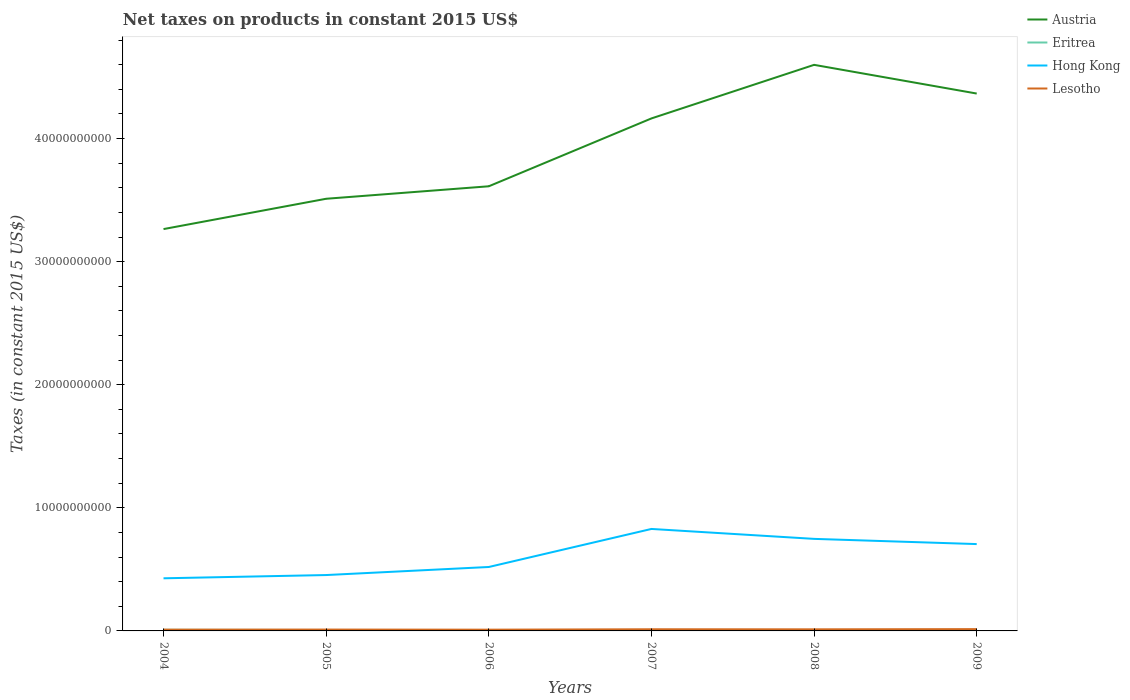Does the line corresponding to Austria intersect with the line corresponding to Lesotho?
Your answer should be very brief. No. Is the number of lines equal to the number of legend labels?
Ensure brevity in your answer.  Yes. Across all years, what is the maximum net taxes on products in Eritrea?
Your answer should be compact. 4.81e+07. In which year was the net taxes on products in Eritrea maximum?
Offer a very short reply. 2008. What is the total net taxes on products in Austria in the graph?
Your response must be concise. -6.53e+09. What is the difference between the highest and the second highest net taxes on products in Eritrea?
Keep it short and to the point. 4.13e+07. Is the net taxes on products in Austria strictly greater than the net taxes on products in Lesotho over the years?
Your answer should be compact. No. How many lines are there?
Provide a succinct answer. 4. Does the graph contain any zero values?
Your answer should be compact. No. Does the graph contain grids?
Keep it short and to the point. No. Where does the legend appear in the graph?
Provide a succinct answer. Top right. How many legend labels are there?
Ensure brevity in your answer.  4. What is the title of the graph?
Provide a succinct answer. Net taxes on products in constant 2015 US$. What is the label or title of the Y-axis?
Provide a short and direct response. Taxes (in constant 2015 US$). What is the Taxes (in constant 2015 US$) of Austria in 2004?
Provide a short and direct response. 3.26e+1. What is the Taxes (in constant 2015 US$) of Eritrea in 2004?
Make the answer very short. 8.94e+07. What is the Taxes (in constant 2015 US$) in Hong Kong in 2004?
Your answer should be very brief. 4.28e+09. What is the Taxes (in constant 2015 US$) of Lesotho in 2004?
Your answer should be very brief. 1.04e+08. What is the Taxes (in constant 2015 US$) in Austria in 2005?
Your answer should be compact. 3.51e+1. What is the Taxes (in constant 2015 US$) of Eritrea in 2005?
Your answer should be very brief. 7.30e+07. What is the Taxes (in constant 2015 US$) in Hong Kong in 2005?
Provide a succinct answer. 4.54e+09. What is the Taxes (in constant 2015 US$) in Lesotho in 2005?
Ensure brevity in your answer.  1.10e+08. What is the Taxes (in constant 2015 US$) of Austria in 2006?
Ensure brevity in your answer.  3.61e+1. What is the Taxes (in constant 2015 US$) of Eritrea in 2006?
Your answer should be very brief. 7.00e+07. What is the Taxes (in constant 2015 US$) of Hong Kong in 2006?
Your response must be concise. 5.19e+09. What is the Taxes (in constant 2015 US$) in Lesotho in 2006?
Your response must be concise. 1.01e+08. What is the Taxes (in constant 2015 US$) of Austria in 2007?
Your answer should be very brief. 4.16e+1. What is the Taxes (in constant 2015 US$) in Eritrea in 2007?
Provide a succinct answer. 5.80e+07. What is the Taxes (in constant 2015 US$) in Hong Kong in 2007?
Your response must be concise. 8.28e+09. What is the Taxes (in constant 2015 US$) in Lesotho in 2007?
Offer a very short reply. 1.34e+08. What is the Taxes (in constant 2015 US$) in Austria in 2008?
Offer a terse response. 4.60e+1. What is the Taxes (in constant 2015 US$) of Eritrea in 2008?
Your answer should be compact. 4.81e+07. What is the Taxes (in constant 2015 US$) of Hong Kong in 2008?
Your answer should be very brief. 7.48e+09. What is the Taxes (in constant 2015 US$) in Lesotho in 2008?
Your answer should be compact. 1.29e+08. What is the Taxes (in constant 2015 US$) of Austria in 2009?
Your answer should be compact. 4.37e+1. What is the Taxes (in constant 2015 US$) in Eritrea in 2009?
Offer a terse response. 5.17e+07. What is the Taxes (in constant 2015 US$) of Hong Kong in 2009?
Make the answer very short. 7.06e+09. What is the Taxes (in constant 2015 US$) of Lesotho in 2009?
Offer a terse response. 1.45e+08. Across all years, what is the maximum Taxes (in constant 2015 US$) in Austria?
Make the answer very short. 4.60e+1. Across all years, what is the maximum Taxes (in constant 2015 US$) in Eritrea?
Provide a succinct answer. 8.94e+07. Across all years, what is the maximum Taxes (in constant 2015 US$) in Hong Kong?
Give a very brief answer. 8.28e+09. Across all years, what is the maximum Taxes (in constant 2015 US$) of Lesotho?
Provide a short and direct response. 1.45e+08. Across all years, what is the minimum Taxes (in constant 2015 US$) in Austria?
Give a very brief answer. 3.26e+1. Across all years, what is the minimum Taxes (in constant 2015 US$) of Eritrea?
Offer a very short reply. 4.81e+07. Across all years, what is the minimum Taxes (in constant 2015 US$) in Hong Kong?
Keep it short and to the point. 4.28e+09. Across all years, what is the minimum Taxes (in constant 2015 US$) of Lesotho?
Provide a succinct answer. 1.01e+08. What is the total Taxes (in constant 2015 US$) in Austria in the graph?
Keep it short and to the point. 2.35e+11. What is the total Taxes (in constant 2015 US$) in Eritrea in the graph?
Your answer should be very brief. 3.90e+08. What is the total Taxes (in constant 2015 US$) in Hong Kong in the graph?
Ensure brevity in your answer.  3.68e+1. What is the total Taxes (in constant 2015 US$) of Lesotho in the graph?
Make the answer very short. 7.24e+08. What is the difference between the Taxes (in constant 2015 US$) in Austria in 2004 and that in 2005?
Keep it short and to the point. -2.46e+09. What is the difference between the Taxes (in constant 2015 US$) of Eritrea in 2004 and that in 2005?
Your answer should be compact. 1.64e+07. What is the difference between the Taxes (in constant 2015 US$) of Hong Kong in 2004 and that in 2005?
Your response must be concise. -2.64e+08. What is the difference between the Taxes (in constant 2015 US$) in Lesotho in 2004 and that in 2005?
Make the answer very short. -6.22e+06. What is the difference between the Taxes (in constant 2015 US$) in Austria in 2004 and that in 2006?
Ensure brevity in your answer.  -3.48e+09. What is the difference between the Taxes (in constant 2015 US$) in Eritrea in 2004 and that in 2006?
Make the answer very short. 1.94e+07. What is the difference between the Taxes (in constant 2015 US$) of Hong Kong in 2004 and that in 2006?
Your answer should be very brief. -9.19e+08. What is the difference between the Taxes (in constant 2015 US$) of Lesotho in 2004 and that in 2006?
Your answer should be very brief. 2.85e+06. What is the difference between the Taxes (in constant 2015 US$) of Austria in 2004 and that in 2007?
Your response must be concise. -8.99e+09. What is the difference between the Taxes (in constant 2015 US$) in Eritrea in 2004 and that in 2007?
Give a very brief answer. 3.14e+07. What is the difference between the Taxes (in constant 2015 US$) in Hong Kong in 2004 and that in 2007?
Your response must be concise. -4.01e+09. What is the difference between the Taxes (in constant 2015 US$) in Lesotho in 2004 and that in 2007?
Provide a short and direct response. -3.01e+07. What is the difference between the Taxes (in constant 2015 US$) in Austria in 2004 and that in 2008?
Ensure brevity in your answer.  -1.33e+1. What is the difference between the Taxes (in constant 2015 US$) in Eritrea in 2004 and that in 2008?
Ensure brevity in your answer.  4.13e+07. What is the difference between the Taxes (in constant 2015 US$) of Hong Kong in 2004 and that in 2008?
Give a very brief answer. -3.20e+09. What is the difference between the Taxes (in constant 2015 US$) of Lesotho in 2004 and that in 2008?
Make the answer very short. -2.51e+07. What is the difference between the Taxes (in constant 2015 US$) in Austria in 2004 and that in 2009?
Your answer should be very brief. -1.10e+1. What is the difference between the Taxes (in constant 2015 US$) in Eritrea in 2004 and that in 2009?
Offer a terse response. 3.77e+07. What is the difference between the Taxes (in constant 2015 US$) of Hong Kong in 2004 and that in 2009?
Your answer should be compact. -2.78e+09. What is the difference between the Taxes (in constant 2015 US$) in Lesotho in 2004 and that in 2009?
Your response must be concise. -4.13e+07. What is the difference between the Taxes (in constant 2015 US$) in Austria in 2005 and that in 2006?
Keep it short and to the point. -1.01e+09. What is the difference between the Taxes (in constant 2015 US$) of Eritrea in 2005 and that in 2006?
Provide a short and direct response. 3.03e+06. What is the difference between the Taxes (in constant 2015 US$) in Hong Kong in 2005 and that in 2006?
Your answer should be very brief. -6.55e+08. What is the difference between the Taxes (in constant 2015 US$) in Lesotho in 2005 and that in 2006?
Offer a very short reply. 9.07e+06. What is the difference between the Taxes (in constant 2015 US$) in Austria in 2005 and that in 2007?
Offer a terse response. -6.53e+09. What is the difference between the Taxes (in constant 2015 US$) in Eritrea in 2005 and that in 2007?
Provide a succinct answer. 1.50e+07. What is the difference between the Taxes (in constant 2015 US$) in Hong Kong in 2005 and that in 2007?
Give a very brief answer. -3.75e+09. What is the difference between the Taxes (in constant 2015 US$) of Lesotho in 2005 and that in 2007?
Your answer should be compact. -2.39e+07. What is the difference between the Taxes (in constant 2015 US$) in Austria in 2005 and that in 2008?
Offer a terse response. -1.09e+1. What is the difference between the Taxes (in constant 2015 US$) of Eritrea in 2005 and that in 2008?
Ensure brevity in your answer.  2.49e+07. What is the difference between the Taxes (in constant 2015 US$) in Hong Kong in 2005 and that in 2008?
Provide a succinct answer. -2.94e+09. What is the difference between the Taxes (in constant 2015 US$) in Lesotho in 2005 and that in 2008?
Offer a very short reply. -1.89e+07. What is the difference between the Taxes (in constant 2015 US$) of Austria in 2005 and that in 2009?
Your answer should be very brief. -8.55e+09. What is the difference between the Taxes (in constant 2015 US$) in Eritrea in 2005 and that in 2009?
Provide a succinct answer. 2.13e+07. What is the difference between the Taxes (in constant 2015 US$) in Hong Kong in 2005 and that in 2009?
Keep it short and to the point. -2.52e+09. What is the difference between the Taxes (in constant 2015 US$) in Lesotho in 2005 and that in 2009?
Your response must be concise. -3.51e+07. What is the difference between the Taxes (in constant 2015 US$) in Austria in 2006 and that in 2007?
Provide a succinct answer. -5.51e+09. What is the difference between the Taxes (in constant 2015 US$) in Eritrea in 2006 and that in 2007?
Your response must be concise. 1.20e+07. What is the difference between the Taxes (in constant 2015 US$) in Hong Kong in 2006 and that in 2007?
Keep it short and to the point. -3.09e+09. What is the difference between the Taxes (in constant 2015 US$) in Lesotho in 2006 and that in 2007?
Your answer should be compact. -3.30e+07. What is the difference between the Taxes (in constant 2015 US$) of Austria in 2006 and that in 2008?
Make the answer very short. -9.87e+09. What is the difference between the Taxes (in constant 2015 US$) of Eritrea in 2006 and that in 2008?
Ensure brevity in your answer.  2.19e+07. What is the difference between the Taxes (in constant 2015 US$) of Hong Kong in 2006 and that in 2008?
Make the answer very short. -2.28e+09. What is the difference between the Taxes (in constant 2015 US$) in Lesotho in 2006 and that in 2008?
Offer a very short reply. -2.80e+07. What is the difference between the Taxes (in constant 2015 US$) of Austria in 2006 and that in 2009?
Provide a short and direct response. -7.53e+09. What is the difference between the Taxes (in constant 2015 US$) of Eritrea in 2006 and that in 2009?
Offer a very short reply. 1.83e+07. What is the difference between the Taxes (in constant 2015 US$) in Hong Kong in 2006 and that in 2009?
Offer a terse response. -1.86e+09. What is the difference between the Taxes (in constant 2015 US$) of Lesotho in 2006 and that in 2009?
Keep it short and to the point. -4.42e+07. What is the difference between the Taxes (in constant 2015 US$) of Austria in 2007 and that in 2008?
Keep it short and to the point. -4.35e+09. What is the difference between the Taxes (in constant 2015 US$) in Eritrea in 2007 and that in 2008?
Provide a succinct answer. 9.89e+06. What is the difference between the Taxes (in constant 2015 US$) in Hong Kong in 2007 and that in 2008?
Your response must be concise. 8.06e+08. What is the difference between the Taxes (in constant 2015 US$) of Lesotho in 2007 and that in 2008?
Your answer should be very brief. 5.00e+06. What is the difference between the Taxes (in constant 2015 US$) in Austria in 2007 and that in 2009?
Your answer should be compact. -2.02e+09. What is the difference between the Taxes (in constant 2015 US$) of Eritrea in 2007 and that in 2009?
Provide a succinct answer. 6.31e+06. What is the difference between the Taxes (in constant 2015 US$) in Hong Kong in 2007 and that in 2009?
Provide a succinct answer. 1.23e+09. What is the difference between the Taxes (in constant 2015 US$) in Lesotho in 2007 and that in 2009?
Your answer should be very brief. -1.12e+07. What is the difference between the Taxes (in constant 2015 US$) in Austria in 2008 and that in 2009?
Your response must be concise. 2.33e+09. What is the difference between the Taxes (in constant 2015 US$) of Eritrea in 2008 and that in 2009?
Give a very brief answer. -3.58e+06. What is the difference between the Taxes (in constant 2015 US$) in Hong Kong in 2008 and that in 2009?
Provide a short and direct response. 4.23e+08. What is the difference between the Taxes (in constant 2015 US$) in Lesotho in 2008 and that in 2009?
Make the answer very short. -1.62e+07. What is the difference between the Taxes (in constant 2015 US$) in Austria in 2004 and the Taxes (in constant 2015 US$) in Eritrea in 2005?
Keep it short and to the point. 3.26e+1. What is the difference between the Taxes (in constant 2015 US$) of Austria in 2004 and the Taxes (in constant 2015 US$) of Hong Kong in 2005?
Make the answer very short. 2.81e+1. What is the difference between the Taxes (in constant 2015 US$) of Austria in 2004 and the Taxes (in constant 2015 US$) of Lesotho in 2005?
Provide a succinct answer. 3.25e+1. What is the difference between the Taxes (in constant 2015 US$) of Eritrea in 2004 and the Taxes (in constant 2015 US$) of Hong Kong in 2005?
Provide a short and direct response. -4.45e+09. What is the difference between the Taxes (in constant 2015 US$) of Eritrea in 2004 and the Taxes (in constant 2015 US$) of Lesotho in 2005?
Give a very brief answer. -2.08e+07. What is the difference between the Taxes (in constant 2015 US$) in Hong Kong in 2004 and the Taxes (in constant 2015 US$) in Lesotho in 2005?
Give a very brief answer. 4.17e+09. What is the difference between the Taxes (in constant 2015 US$) of Austria in 2004 and the Taxes (in constant 2015 US$) of Eritrea in 2006?
Provide a succinct answer. 3.26e+1. What is the difference between the Taxes (in constant 2015 US$) of Austria in 2004 and the Taxes (in constant 2015 US$) of Hong Kong in 2006?
Ensure brevity in your answer.  2.75e+1. What is the difference between the Taxes (in constant 2015 US$) of Austria in 2004 and the Taxes (in constant 2015 US$) of Lesotho in 2006?
Your answer should be very brief. 3.25e+1. What is the difference between the Taxes (in constant 2015 US$) in Eritrea in 2004 and the Taxes (in constant 2015 US$) in Hong Kong in 2006?
Ensure brevity in your answer.  -5.10e+09. What is the difference between the Taxes (in constant 2015 US$) of Eritrea in 2004 and the Taxes (in constant 2015 US$) of Lesotho in 2006?
Offer a very short reply. -1.17e+07. What is the difference between the Taxes (in constant 2015 US$) in Hong Kong in 2004 and the Taxes (in constant 2015 US$) in Lesotho in 2006?
Offer a very short reply. 4.17e+09. What is the difference between the Taxes (in constant 2015 US$) in Austria in 2004 and the Taxes (in constant 2015 US$) in Eritrea in 2007?
Offer a very short reply. 3.26e+1. What is the difference between the Taxes (in constant 2015 US$) of Austria in 2004 and the Taxes (in constant 2015 US$) of Hong Kong in 2007?
Your response must be concise. 2.44e+1. What is the difference between the Taxes (in constant 2015 US$) in Austria in 2004 and the Taxes (in constant 2015 US$) in Lesotho in 2007?
Offer a very short reply. 3.25e+1. What is the difference between the Taxes (in constant 2015 US$) in Eritrea in 2004 and the Taxes (in constant 2015 US$) in Hong Kong in 2007?
Ensure brevity in your answer.  -8.20e+09. What is the difference between the Taxes (in constant 2015 US$) of Eritrea in 2004 and the Taxes (in constant 2015 US$) of Lesotho in 2007?
Your answer should be compact. -4.47e+07. What is the difference between the Taxes (in constant 2015 US$) in Hong Kong in 2004 and the Taxes (in constant 2015 US$) in Lesotho in 2007?
Your response must be concise. 4.14e+09. What is the difference between the Taxes (in constant 2015 US$) in Austria in 2004 and the Taxes (in constant 2015 US$) in Eritrea in 2008?
Keep it short and to the point. 3.26e+1. What is the difference between the Taxes (in constant 2015 US$) in Austria in 2004 and the Taxes (in constant 2015 US$) in Hong Kong in 2008?
Ensure brevity in your answer.  2.52e+1. What is the difference between the Taxes (in constant 2015 US$) in Austria in 2004 and the Taxes (in constant 2015 US$) in Lesotho in 2008?
Your response must be concise. 3.25e+1. What is the difference between the Taxes (in constant 2015 US$) of Eritrea in 2004 and the Taxes (in constant 2015 US$) of Hong Kong in 2008?
Your answer should be compact. -7.39e+09. What is the difference between the Taxes (in constant 2015 US$) of Eritrea in 2004 and the Taxes (in constant 2015 US$) of Lesotho in 2008?
Provide a short and direct response. -3.97e+07. What is the difference between the Taxes (in constant 2015 US$) of Hong Kong in 2004 and the Taxes (in constant 2015 US$) of Lesotho in 2008?
Provide a succinct answer. 4.15e+09. What is the difference between the Taxes (in constant 2015 US$) of Austria in 2004 and the Taxes (in constant 2015 US$) of Eritrea in 2009?
Give a very brief answer. 3.26e+1. What is the difference between the Taxes (in constant 2015 US$) in Austria in 2004 and the Taxes (in constant 2015 US$) in Hong Kong in 2009?
Provide a succinct answer. 2.56e+1. What is the difference between the Taxes (in constant 2015 US$) of Austria in 2004 and the Taxes (in constant 2015 US$) of Lesotho in 2009?
Provide a succinct answer. 3.25e+1. What is the difference between the Taxes (in constant 2015 US$) in Eritrea in 2004 and the Taxes (in constant 2015 US$) in Hong Kong in 2009?
Offer a very short reply. -6.97e+09. What is the difference between the Taxes (in constant 2015 US$) of Eritrea in 2004 and the Taxes (in constant 2015 US$) of Lesotho in 2009?
Provide a succinct answer. -5.59e+07. What is the difference between the Taxes (in constant 2015 US$) of Hong Kong in 2004 and the Taxes (in constant 2015 US$) of Lesotho in 2009?
Your answer should be very brief. 4.13e+09. What is the difference between the Taxes (in constant 2015 US$) in Austria in 2005 and the Taxes (in constant 2015 US$) in Eritrea in 2006?
Offer a terse response. 3.50e+1. What is the difference between the Taxes (in constant 2015 US$) in Austria in 2005 and the Taxes (in constant 2015 US$) in Hong Kong in 2006?
Your answer should be compact. 2.99e+1. What is the difference between the Taxes (in constant 2015 US$) in Austria in 2005 and the Taxes (in constant 2015 US$) in Lesotho in 2006?
Offer a very short reply. 3.50e+1. What is the difference between the Taxes (in constant 2015 US$) of Eritrea in 2005 and the Taxes (in constant 2015 US$) of Hong Kong in 2006?
Provide a succinct answer. -5.12e+09. What is the difference between the Taxes (in constant 2015 US$) of Eritrea in 2005 and the Taxes (in constant 2015 US$) of Lesotho in 2006?
Provide a short and direct response. -2.81e+07. What is the difference between the Taxes (in constant 2015 US$) in Hong Kong in 2005 and the Taxes (in constant 2015 US$) in Lesotho in 2006?
Provide a succinct answer. 4.44e+09. What is the difference between the Taxes (in constant 2015 US$) in Austria in 2005 and the Taxes (in constant 2015 US$) in Eritrea in 2007?
Ensure brevity in your answer.  3.51e+1. What is the difference between the Taxes (in constant 2015 US$) of Austria in 2005 and the Taxes (in constant 2015 US$) of Hong Kong in 2007?
Your response must be concise. 2.68e+1. What is the difference between the Taxes (in constant 2015 US$) of Austria in 2005 and the Taxes (in constant 2015 US$) of Lesotho in 2007?
Your response must be concise. 3.50e+1. What is the difference between the Taxes (in constant 2015 US$) in Eritrea in 2005 and the Taxes (in constant 2015 US$) in Hong Kong in 2007?
Your answer should be very brief. -8.21e+09. What is the difference between the Taxes (in constant 2015 US$) in Eritrea in 2005 and the Taxes (in constant 2015 US$) in Lesotho in 2007?
Offer a terse response. -6.11e+07. What is the difference between the Taxes (in constant 2015 US$) of Hong Kong in 2005 and the Taxes (in constant 2015 US$) of Lesotho in 2007?
Make the answer very short. 4.41e+09. What is the difference between the Taxes (in constant 2015 US$) of Austria in 2005 and the Taxes (in constant 2015 US$) of Eritrea in 2008?
Provide a succinct answer. 3.51e+1. What is the difference between the Taxes (in constant 2015 US$) of Austria in 2005 and the Taxes (in constant 2015 US$) of Hong Kong in 2008?
Your response must be concise. 2.76e+1. What is the difference between the Taxes (in constant 2015 US$) of Austria in 2005 and the Taxes (in constant 2015 US$) of Lesotho in 2008?
Offer a terse response. 3.50e+1. What is the difference between the Taxes (in constant 2015 US$) in Eritrea in 2005 and the Taxes (in constant 2015 US$) in Hong Kong in 2008?
Your response must be concise. -7.41e+09. What is the difference between the Taxes (in constant 2015 US$) of Eritrea in 2005 and the Taxes (in constant 2015 US$) of Lesotho in 2008?
Your answer should be very brief. -5.61e+07. What is the difference between the Taxes (in constant 2015 US$) in Hong Kong in 2005 and the Taxes (in constant 2015 US$) in Lesotho in 2008?
Give a very brief answer. 4.41e+09. What is the difference between the Taxes (in constant 2015 US$) in Austria in 2005 and the Taxes (in constant 2015 US$) in Eritrea in 2009?
Your answer should be very brief. 3.51e+1. What is the difference between the Taxes (in constant 2015 US$) in Austria in 2005 and the Taxes (in constant 2015 US$) in Hong Kong in 2009?
Give a very brief answer. 2.81e+1. What is the difference between the Taxes (in constant 2015 US$) in Austria in 2005 and the Taxes (in constant 2015 US$) in Lesotho in 2009?
Offer a terse response. 3.50e+1. What is the difference between the Taxes (in constant 2015 US$) in Eritrea in 2005 and the Taxes (in constant 2015 US$) in Hong Kong in 2009?
Keep it short and to the point. -6.98e+09. What is the difference between the Taxes (in constant 2015 US$) in Eritrea in 2005 and the Taxes (in constant 2015 US$) in Lesotho in 2009?
Ensure brevity in your answer.  -7.23e+07. What is the difference between the Taxes (in constant 2015 US$) in Hong Kong in 2005 and the Taxes (in constant 2015 US$) in Lesotho in 2009?
Your response must be concise. 4.39e+09. What is the difference between the Taxes (in constant 2015 US$) of Austria in 2006 and the Taxes (in constant 2015 US$) of Eritrea in 2007?
Your response must be concise. 3.61e+1. What is the difference between the Taxes (in constant 2015 US$) in Austria in 2006 and the Taxes (in constant 2015 US$) in Hong Kong in 2007?
Offer a terse response. 2.78e+1. What is the difference between the Taxes (in constant 2015 US$) of Austria in 2006 and the Taxes (in constant 2015 US$) of Lesotho in 2007?
Make the answer very short. 3.60e+1. What is the difference between the Taxes (in constant 2015 US$) in Eritrea in 2006 and the Taxes (in constant 2015 US$) in Hong Kong in 2007?
Your answer should be compact. -8.21e+09. What is the difference between the Taxes (in constant 2015 US$) of Eritrea in 2006 and the Taxes (in constant 2015 US$) of Lesotho in 2007?
Offer a terse response. -6.42e+07. What is the difference between the Taxes (in constant 2015 US$) in Hong Kong in 2006 and the Taxes (in constant 2015 US$) in Lesotho in 2007?
Offer a very short reply. 5.06e+09. What is the difference between the Taxes (in constant 2015 US$) of Austria in 2006 and the Taxes (in constant 2015 US$) of Eritrea in 2008?
Provide a short and direct response. 3.61e+1. What is the difference between the Taxes (in constant 2015 US$) of Austria in 2006 and the Taxes (in constant 2015 US$) of Hong Kong in 2008?
Provide a short and direct response. 2.86e+1. What is the difference between the Taxes (in constant 2015 US$) of Austria in 2006 and the Taxes (in constant 2015 US$) of Lesotho in 2008?
Give a very brief answer. 3.60e+1. What is the difference between the Taxes (in constant 2015 US$) in Eritrea in 2006 and the Taxes (in constant 2015 US$) in Hong Kong in 2008?
Your answer should be compact. -7.41e+09. What is the difference between the Taxes (in constant 2015 US$) in Eritrea in 2006 and the Taxes (in constant 2015 US$) in Lesotho in 2008?
Your answer should be very brief. -5.92e+07. What is the difference between the Taxes (in constant 2015 US$) of Hong Kong in 2006 and the Taxes (in constant 2015 US$) of Lesotho in 2008?
Your response must be concise. 5.07e+09. What is the difference between the Taxes (in constant 2015 US$) of Austria in 2006 and the Taxes (in constant 2015 US$) of Eritrea in 2009?
Make the answer very short. 3.61e+1. What is the difference between the Taxes (in constant 2015 US$) of Austria in 2006 and the Taxes (in constant 2015 US$) of Hong Kong in 2009?
Offer a very short reply. 2.91e+1. What is the difference between the Taxes (in constant 2015 US$) of Austria in 2006 and the Taxes (in constant 2015 US$) of Lesotho in 2009?
Your answer should be compact. 3.60e+1. What is the difference between the Taxes (in constant 2015 US$) of Eritrea in 2006 and the Taxes (in constant 2015 US$) of Hong Kong in 2009?
Make the answer very short. -6.99e+09. What is the difference between the Taxes (in constant 2015 US$) of Eritrea in 2006 and the Taxes (in constant 2015 US$) of Lesotho in 2009?
Offer a terse response. -7.54e+07. What is the difference between the Taxes (in constant 2015 US$) of Hong Kong in 2006 and the Taxes (in constant 2015 US$) of Lesotho in 2009?
Ensure brevity in your answer.  5.05e+09. What is the difference between the Taxes (in constant 2015 US$) in Austria in 2007 and the Taxes (in constant 2015 US$) in Eritrea in 2008?
Provide a short and direct response. 4.16e+1. What is the difference between the Taxes (in constant 2015 US$) in Austria in 2007 and the Taxes (in constant 2015 US$) in Hong Kong in 2008?
Your answer should be compact. 3.42e+1. What is the difference between the Taxes (in constant 2015 US$) of Austria in 2007 and the Taxes (in constant 2015 US$) of Lesotho in 2008?
Offer a terse response. 4.15e+1. What is the difference between the Taxes (in constant 2015 US$) in Eritrea in 2007 and the Taxes (in constant 2015 US$) in Hong Kong in 2008?
Provide a succinct answer. -7.42e+09. What is the difference between the Taxes (in constant 2015 US$) in Eritrea in 2007 and the Taxes (in constant 2015 US$) in Lesotho in 2008?
Offer a very short reply. -7.11e+07. What is the difference between the Taxes (in constant 2015 US$) of Hong Kong in 2007 and the Taxes (in constant 2015 US$) of Lesotho in 2008?
Your answer should be compact. 8.16e+09. What is the difference between the Taxes (in constant 2015 US$) in Austria in 2007 and the Taxes (in constant 2015 US$) in Eritrea in 2009?
Keep it short and to the point. 4.16e+1. What is the difference between the Taxes (in constant 2015 US$) of Austria in 2007 and the Taxes (in constant 2015 US$) of Hong Kong in 2009?
Your answer should be very brief. 3.46e+1. What is the difference between the Taxes (in constant 2015 US$) of Austria in 2007 and the Taxes (in constant 2015 US$) of Lesotho in 2009?
Offer a very short reply. 4.15e+1. What is the difference between the Taxes (in constant 2015 US$) of Eritrea in 2007 and the Taxes (in constant 2015 US$) of Hong Kong in 2009?
Offer a very short reply. -7.00e+09. What is the difference between the Taxes (in constant 2015 US$) of Eritrea in 2007 and the Taxes (in constant 2015 US$) of Lesotho in 2009?
Your response must be concise. -8.73e+07. What is the difference between the Taxes (in constant 2015 US$) of Hong Kong in 2007 and the Taxes (in constant 2015 US$) of Lesotho in 2009?
Give a very brief answer. 8.14e+09. What is the difference between the Taxes (in constant 2015 US$) of Austria in 2008 and the Taxes (in constant 2015 US$) of Eritrea in 2009?
Keep it short and to the point. 4.59e+1. What is the difference between the Taxes (in constant 2015 US$) in Austria in 2008 and the Taxes (in constant 2015 US$) in Hong Kong in 2009?
Offer a terse response. 3.89e+1. What is the difference between the Taxes (in constant 2015 US$) in Austria in 2008 and the Taxes (in constant 2015 US$) in Lesotho in 2009?
Provide a short and direct response. 4.58e+1. What is the difference between the Taxes (in constant 2015 US$) of Eritrea in 2008 and the Taxes (in constant 2015 US$) of Hong Kong in 2009?
Offer a very short reply. -7.01e+09. What is the difference between the Taxes (in constant 2015 US$) of Eritrea in 2008 and the Taxes (in constant 2015 US$) of Lesotho in 2009?
Give a very brief answer. -9.72e+07. What is the difference between the Taxes (in constant 2015 US$) of Hong Kong in 2008 and the Taxes (in constant 2015 US$) of Lesotho in 2009?
Offer a very short reply. 7.33e+09. What is the average Taxes (in constant 2015 US$) of Austria per year?
Ensure brevity in your answer.  3.92e+1. What is the average Taxes (in constant 2015 US$) of Eritrea per year?
Offer a very short reply. 6.50e+07. What is the average Taxes (in constant 2015 US$) of Hong Kong per year?
Provide a short and direct response. 6.14e+09. What is the average Taxes (in constant 2015 US$) in Lesotho per year?
Provide a succinct answer. 1.21e+08. In the year 2004, what is the difference between the Taxes (in constant 2015 US$) in Austria and Taxes (in constant 2015 US$) in Eritrea?
Your response must be concise. 3.26e+1. In the year 2004, what is the difference between the Taxes (in constant 2015 US$) of Austria and Taxes (in constant 2015 US$) of Hong Kong?
Offer a terse response. 2.84e+1. In the year 2004, what is the difference between the Taxes (in constant 2015 US$) of Austria and Taxes (in constant 2015 US$) of Lesotho?
Offer a terse response. 3.25e+1. In the year 2004, what is the difference between the Taxes (in constant 2015 US$) in Eritrea and Taxes (in constant 2015 US$) in Hong Kong?
Ensure brevity in your answer.  -4.19e+09. In the year 2004, what is the difference between the Taxes (in constant 2015 US$) in Eritrea and Taxes (in constant 2015 US$) in Lesotho?
Your answer should be compact. -1.46e+07. In the year 2004, what is the difference between the Taxes (in constant 2015 US$) in Hong Kong and Taxes (in constant 2015 US$) in Lesotho?
Provide a short and direct response. 4.17e+09. In the year 2005, what is the difference between the Taxes (in constant 2015 US$) in Austria and Taxes (in constant 2015 US$) in Eritrea?
Offer a very short reply. 3.50e+1. In the year 2005, what is the difference between the Taxes (in constant 2015 US$) of Austria and Taxes (in constant 2015 US$) of Hong Kong?
Give a very brief answer. 3.06e+1. In the year 2005, what is the difference between the Taxes (in constant 2015 US$) of Austria and Taxes (in constant 2015 US$) of Lesotho?
Ensure brevity in your answer.  3.50e+1. In the year 2005, what is the difference between the Taxes (in constant 2015 US$) in Eritrea and Taxes (in constant 2015 US$) in Hong Kong?
Provide a short and direct response. -4.47e+09. In the year 2005, what is the difference between the Taxes (in constant 2015 US$) in Eritrea and Taxes (in constant 2015 US$) in Lesotho?
Your answer should be very brief. -3.72e+07. In the year 2005, what is the difference between the Taxes (in constant 2015 US$) of Hong Kong and Taxes (in constant 2015 US$) of Lesotho?
Your answer should be compact. 4.43e+09. In the year 2006, what is the difference between the Taxes (in constant 2015 US$) of Austria and Taxes (in constant 2015 US$) of Eritrea?
Keep it short and to the point. 3.61e+1. In the year 2006, what is the difference between the Taxes (in constant 2015 US$) in Austria and Taxes (in constant 2015 US$) in Hong Kong?
Offer a very short reply. 3.09e+1. In the year 2006, what is the difference between the Taxes (in constant 2015 US$) in Austria and Taxes (in constant 2015 US$) in Lesotho?
Make the answer very short. 3.60e+1. In the year 2006, what is the difference between the Taxes (in constant 2015 US$) in Eritrea and Taxes (in constant 2015 US$) in Hong Kong?
Keep it short and to the point. -5.12e+09. In the year 2006, what is the difference between the Taxes (in constant 2015 US$) of Eritrea and Taxes (in constant 2015 US$) of Lesotho?
Make the answer very short. -3.12e+07. In the year 2006, what is the difference between the Taxes (in constant 2015 US$) of Hong Kong and Taxes (in constant 2015 US$) of Lesotho?
Provide a short and direct response. 5.09e+09. In the year 2007, what is the difference between the Taxes (in constant 2015 US$) in Austria and Taxes (in constant 2015 US$) in Eritrea?
Your answer should be compact. 4.16e+1. In the year 2007, what is the difference between the Taxes (in constant 2015 US$) in Austria and Taxes (in constant 2015 US$) in Hong Kong?
Provide a succinct answer. 3.34e+1. In the year 2007, what is the difference between the Taxes (in constant 2015 US$) in Austria and Taxes (in constant 2015 US$) in Lesotho?
Keep it short and to the point. 4.15e+1. In the year 2007, what is the difference between the Taxes (in constant 2015 US$) of Eritrea and Taxes (in constant 2015 US$) of Hong Kong?
Provide a short and direct response. -8.23e+09. In the year 2007, what is the difference between the Taxes (in constant 2015 US$) in Eritrea and Taxes (in constant 2015 US$) in Lesotho?
Your response must be concise. -7.61e+07. In the year 2007, what is the difference between the Taxes (in constant 2015 US$) in Hong Kong and Taxes (in constant 2015 US$) in Lesotho?
Provide a short and direct response. 8.15e+09. In the year 2008, what is the difference between the Taxes (in constant 2015 US$) in Austria and Taxes (in constant 2015 US$) in Eritrea?
Your answer should be very brief. 4.59e+1. In the year 2008, what is the difference between the Taxes (in constant 2015 US$) of Austria and Taxes (in constant 2015 US$) of Hong Kong?
Provide a short and direct response. 3.85e+1. In the year 2008, what is the difference between the Taxes (in constant 2015 US$) in Austria and Taxes (in constant 2015 US$) in Lesotho?
Your answer should be very brief. 4.59e+1. In the year 2008, what is the difference between the Taxes (in constant 2015 US$) in Eritrea and Taxes (in constant 2015 US$) in Hong Kong?
Provide a short and direct response. -7.43e+09. In the year 2008, what is the difference between the Taxes (in constant 2015 US$) in Eritrea and Taxes (in constant 2015 US$) in Lesotho?
Offer a terse response. -8.10e+07. In the year 2008, what is the difference between the Taxes (in constant 2015 US$) of Hong Kong and Taxes (in constant 2015 US$) of Lesotho?
Give a very brief answer. 7.35e+09. In the year 2009, what is the difference between the Taxes (in constant 2015 US$) in Austria and Taxes (in constant 2015 US$) in Eritrea?
Provide a short and direct response. 4.36e+1. In the year 2009, what is the difference between the Taxes (in constant 2015 US$) of Austria and Taxes (in constant 2015 US$) of Hong Kong?
Provide a short and direct response. 3.66e+1. In the year 2009, what is the difference between the Taxes (in constant 2015 US$) in Austria and Taxes (in constant 2015 US$) in Lesotho?
Your answer should be compact. 4.35e+1. In the year 2009, what is the difference between the Taxes (in constant 2015 US$) of Eritrea and Taxes (in constant 2015 US$) of Hong Kong?
Your answer should be compact. -7.00e+09. In the year 2009, what is the difference between the Taxes (in constant 2015 US$) in Eritrea and Taxes (in constant 2015 US$) in Lesotho?
Your response must be concise. -9.36e+07. In the year 2009, what is the difference between the Taxes (in constant 2015 US$) of Hong Kong and Taxes (in constant 2015 US$) of Lesotho?
Offer a terse response. 6.91e+09. What is the ratio of the Taxes (in constant 2015 US$) in Austria in 2004 to that in 2005?
Offer a very short reply. 0.93. What is the ratio of the Taxes (in constant 2015 US$) in Eritrea in 2004 to that in 2005?
Your answer should be compact. 1.22. What is the ratio of the Taxes (in constant 2015 US$) in Hong Kong in 2004 to that in 2005?
Keep it short and to the point. 0.94. What is the ratio of the Taxes (in constant 2015 US$) in Lesotho in 2004 to that in 2005?
Your answer should be compact. 0.94. What is the ratio of the Taxes (in constant 2015 US$) of Austria in 2004 to that in 2006?
Provide a short and direct response. 0.9. What is the ratio of the Taxes (in constant 2015 US$) of Eritrea in 2004 to that in 2006?
Make the answer very short. 1.28. What is the ratio of the Taxes (in constant 2015 US$) of Hong Kong in 2004 to that in 2006?
Keep it short and to the point. 0.82. What is the ratio of the Taxes (in constant 2015 US$) in Lesotho in 2004 to that in 2006?
Provide a short and direct response. 1.03. What is the ratio of the Taxes (in constant 2015 US$) in Austria in 2004 to that in 2007?
Provide a short and direct response. 0.78. What is the ratio of the Taxes (in constant 2015 US$) in Eritrea in 2004 to that in 2007?
Provide a succinct answer. 1.54. What is the ratio of the Taxes (in constant 2015 US$) in Hong Kong in 2004 to that in 2007?
Your answer should be compact. 0.52. What is the ratio of the Taxes (in constant 2015 US$) in Lesotho in 2004 to that in 2007?
Give a very brief answer. 0.78. What is the ratio of the Taxes (in constant 2015 US$) of Austria in 2004 to that in 2008?
Provide a short and direct response. 0.71. What is the ratio of the Taxes (in constant 2015 US$) in Eritrea in 2004 to that in 2008?
Provide a succinct answer. 1.86. What is the ratio of the Taxes (in constant 2015 US$) of Hong Kong in 2004 to that in 2008?
Your answer should be very brief. 0.57. What is the ratio of the Taxes (in constant 2015 US$) of Lesotho in 2004 to that in 2008?
Provide a short and direct response. 0.81. What is the ratio of the Taxes (in constant 2015 US$) in Austria in 2004 to that in 2009?
Your answer should be very brief. 0.75. What is the ratio of the Taxes (in constant 2015 US$) in Eritrea in 2004 to that in 2009?
Give a very brief answer. 1.73. What is the ratio of the Taxes (in constant 2015 US$) of Hong Kong in 2004 to that in 2009?
Your answer should be compact. 0.61. What is the ratio of the Taxes (in constant 2015 US$) in Lesotho in 2004 to that in 2009?
Make the answer very short. 0.72. What is the ratio of the Taxes (in constant 2015 US$) in Austria in 2005 to that in 2006?
Provide a succinct answer. 0.97. What is the ratio of the Taxes (in constant 2015 US$) in Eritrea in 2005 to that in 2006?
Provide a short and direct response. 1.04. What is the ratio of the Taxes (in constant 2015 US$) of Hong Kong in 2005 to that in 2006?
Offer a very short reply. 0.87. What is the ratio of the Taxes (in constant 2015 US$) in Lesotho in 2005 to that in 2006?
Keep it short and to the point. 1.09. What is the ratio of the Taxes (in constant 2015 US$) in Austria in 2005 to that in 2007?
Offer a very short reply. 0.84. What is the ratio of the Taxes (in constant 2015 US$) in Eritrea in 2005 to that in 2007?
Your response must be concise. 1.26. What is the ratio of the Taxes (in constant 2015 US$) in Hong Kong in 2005 to that in 2007?
Keep it short and to the point. 0.55. What is the ratio of the Taxes (in constant 2015 US$) of Lesotho in 2005 to that in 2007?
Your answer should be very brief. 0.82. What is the ratio of the Taxes (in constant 2015 US$) of Austria in 2005 to that in 2008?
Keep it short and to the point. 0.76. What is the ratio of the Taxes (in constant 2015 US$) of Eritrea in 2005 to that in 2008?
Give a very brief answer. 1.52. What is the ratio of the Taxes (in constant 2015 US$) in Hong Kong in 2005 to that in 2008?
Offer a terse response. 0.61. What is the ratio of the Taxes (in constant 2015 US$) in Lesotho in 2005 to that in 2008?
Provide a short and direct response. 0.85. What is the ratio of the Taxes (in constant 2015 US$) in Austria in 2005 to that in 2009?
Your answer should be compact. 0.8. What is the ratio of the Taxes (in constant 2015 US$) of Eritrea in 2005 to that in 2009?
Ensure brevity in your answer.  1.41. What is the ratio of the Taxes (in constant 2015 US$) of Hong Kong in 2005 to that in 2009?
Ensure brevity in your answer.  0.64. What is the ratio of the Taxes (in constant 2015 US$) of Lesotho in 2005 to that in 2009?
Offer a very short reply. 0.76. What is the ratio of the Taxes (in constant 2015 US$) of Austria in 2006 to that in 2007?
Ensure brevity in your answer.  0.87. What is the ratio of the Taxes (in constant 2015 US$) in Eritrea in 2006 to that in 2007?
Keep it short and to the point. 1.21. What is the ratio of the Taxes (in constant 2015 US$) in Hong Kong in 2006 to that in 2007?
Offer a terse response. 0.63. What is the ratio of the Taxes (in constant 2015 US$) in Lesotho in 2006 to that in 2007?
Offer a terse response. 0.75. What is the ratio of the Taxes (in constant 2015 US$) in Austria in 2006 to that in 2008?
Your answer should be very brief. 0.79. What is the ratio of the Taxes (in constant 2015 US$) of Eritrea in 2006 to that in 2008?
Make the answer very short. 1.45. What is the ratio of the Taxes (in constant 2015 US$) of Hong Kong in 2006 to that in 2008?
Provide a short and direct response. 0.69. What is the ratio of the Taxes (in constant 2015 US$) in Lesotho in 2006 to that in 2008?
Make the answer very short. 0.78. What is the ratio of the Taxes (in constant 2015 US$) in Austria in 2006 to that in 2009?
Offer a very short reply. 0.83. What is the ratio of the Taxes (in constant 2015 US$) in Eritrea in 2006 to that in 2009?
Your answer should be compact. 1.35. What is the ratio of the Taxes (in constant 2015 US$) in Hong Kong in 2006 to that in 2009?
Provide a short and direct response. 0.74. What is the ratio of the Taxes (in constant 2015 US$) in Lesotho in 2006 to that in 2009?
Provide a short and direct response. 0.7. What is the ratio of the Taxes (in constant 2015 US$) of Austria in 2007 to that in 2008?
Make the answer very short. 0.91. What is the ratio of the Taxes (in constant 2015 US$) in Eritrea in 2007 to that in 2008?
Give a very brief answer. 1.21. What is the ratio of the Taxes (in constant 2015 US$) of Hong Kong in 2007 to that in 2008?
Your response must be concise. 1.11. What is the ratio of the Taxes (in constant 2015 US$) in Lesotho in 2007 to that in 2008?
Your response must be concise. 1.04. What is the ratio of the Taxes (in constant 2015 US$) of Austria in 2007 to that in 2009?
Your answer should be very brief. 0.95. What is the ratio of the Taxes (in constant 2015 US$) of Eritrea in 2007 to that in 2009?
Keep it short and to the point. 1.12. What is the ratio of the Taxes (in constant 2015 US$) of Hong Kong in 2007 to that in 2009?
Offer a very short reply. 1.17. What is the ratio of the Taxes (in constant 2015 US$) of Lesotho in 2007 to that in 2009?
Keep it short and to the point. 0.92. What is the ratio of the Taxes (in constant 2015 US$) in Austria in 2008 to that in 2009?
Provide a succinct answer. 1.05. What is the ratio of the Taxes (in constant 2015 US$) of Eritrea in 2008 to that in 2009?
Make the answer very short. 0.93. What is the ratio of the Taxes (in constant 2015 US$) in Hong Kong in 2008 to that in 2009?
Your answer should be compact. 1.06. What is the ratio of the Taxes (in constant 2015 US$) of Lesotho in 2008 to that in 2009?
Give a very brief answer. 0.89. What is the difference between the highest and the second highest Taxes (in constant 2015 US$) of Austria?
Your answer should be very brief. 2.33e+09. What is the difference between the highest and the second highest Taxes (in constant 2015 US$) in Eritrea?
Give a very brief answer. 1.64e+07. What is the difference between the highest and the second highest Taxes (in constant 2015 US$) of Hong Kong?
Your response must be concise. 8.06e+08. What is the difference between the highest and the second highest Taxes (in constant 2015 US$) in Lesotho?
Keep it short and to the point. 1.12e+07. What is the difference between the highest and the lowest Taxes (in constant 2015 US$) in Austria?
Offer a very short reply. 1.33e+1. What is the difference between the highest and the lowest Taxes (in constant 2015 US$) of Eritrea?
Your answer should be very brief. 4.13e+07. What is the difference between the highest and the lowest Taxes (in constant 2015 US$) in Hong Kong?
Your answer should be compact. 4.01e+09. What is the difference between the highest and the lowest Taxes (in constant 2015 US$) of Lesotho?
Offer a very short reply. 4.42e+07. 